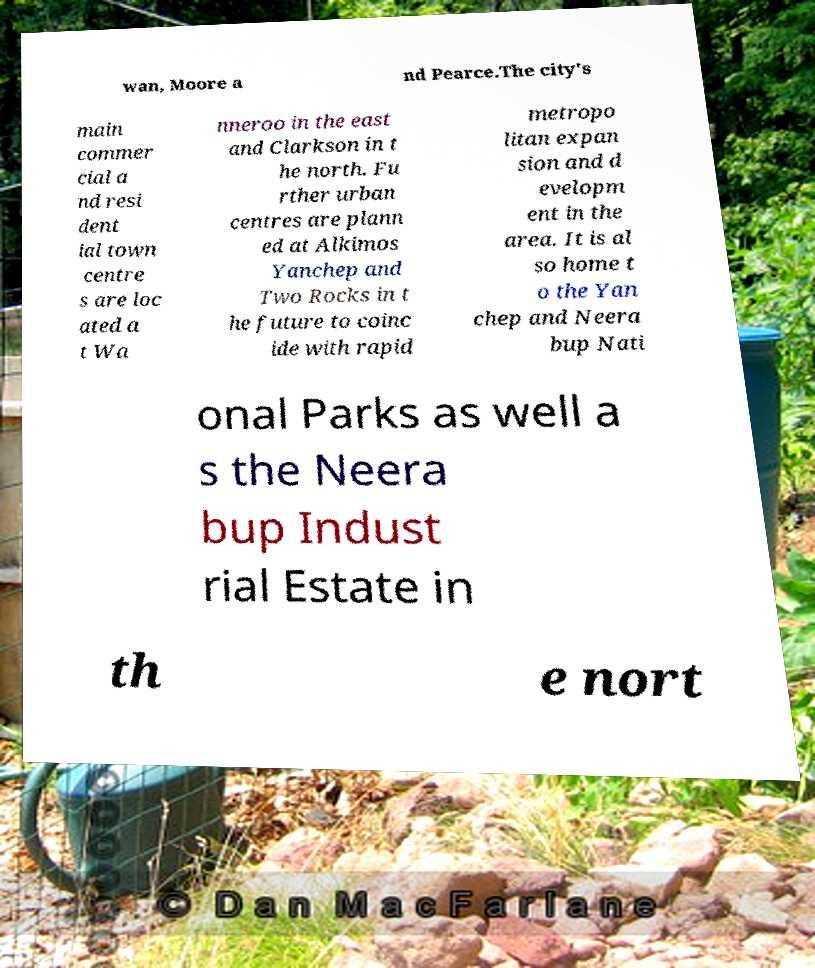Can you accurately transcribe the text from the provided image for me? wan, Moore a nd Pearce.The city's main commer cial a nd resi dent ial town centre s are loc ated a t Wa nneroo in the east and Clarkson in t he north. Fu rther urban centres are plann ed at Alkimos Yanchep and Two Rocks in t he future to coinc ide with rapid metropo litan expan sion and d evelopm ent in the area. It is al so home t o the Yan chep and Neera bup Nati onal Parks as well a s the Neera bup Indust rial Estate in th e nort 